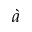<formula> <loc_0><loc_0><loc_500><loc_500>\grave { a }</formula> 